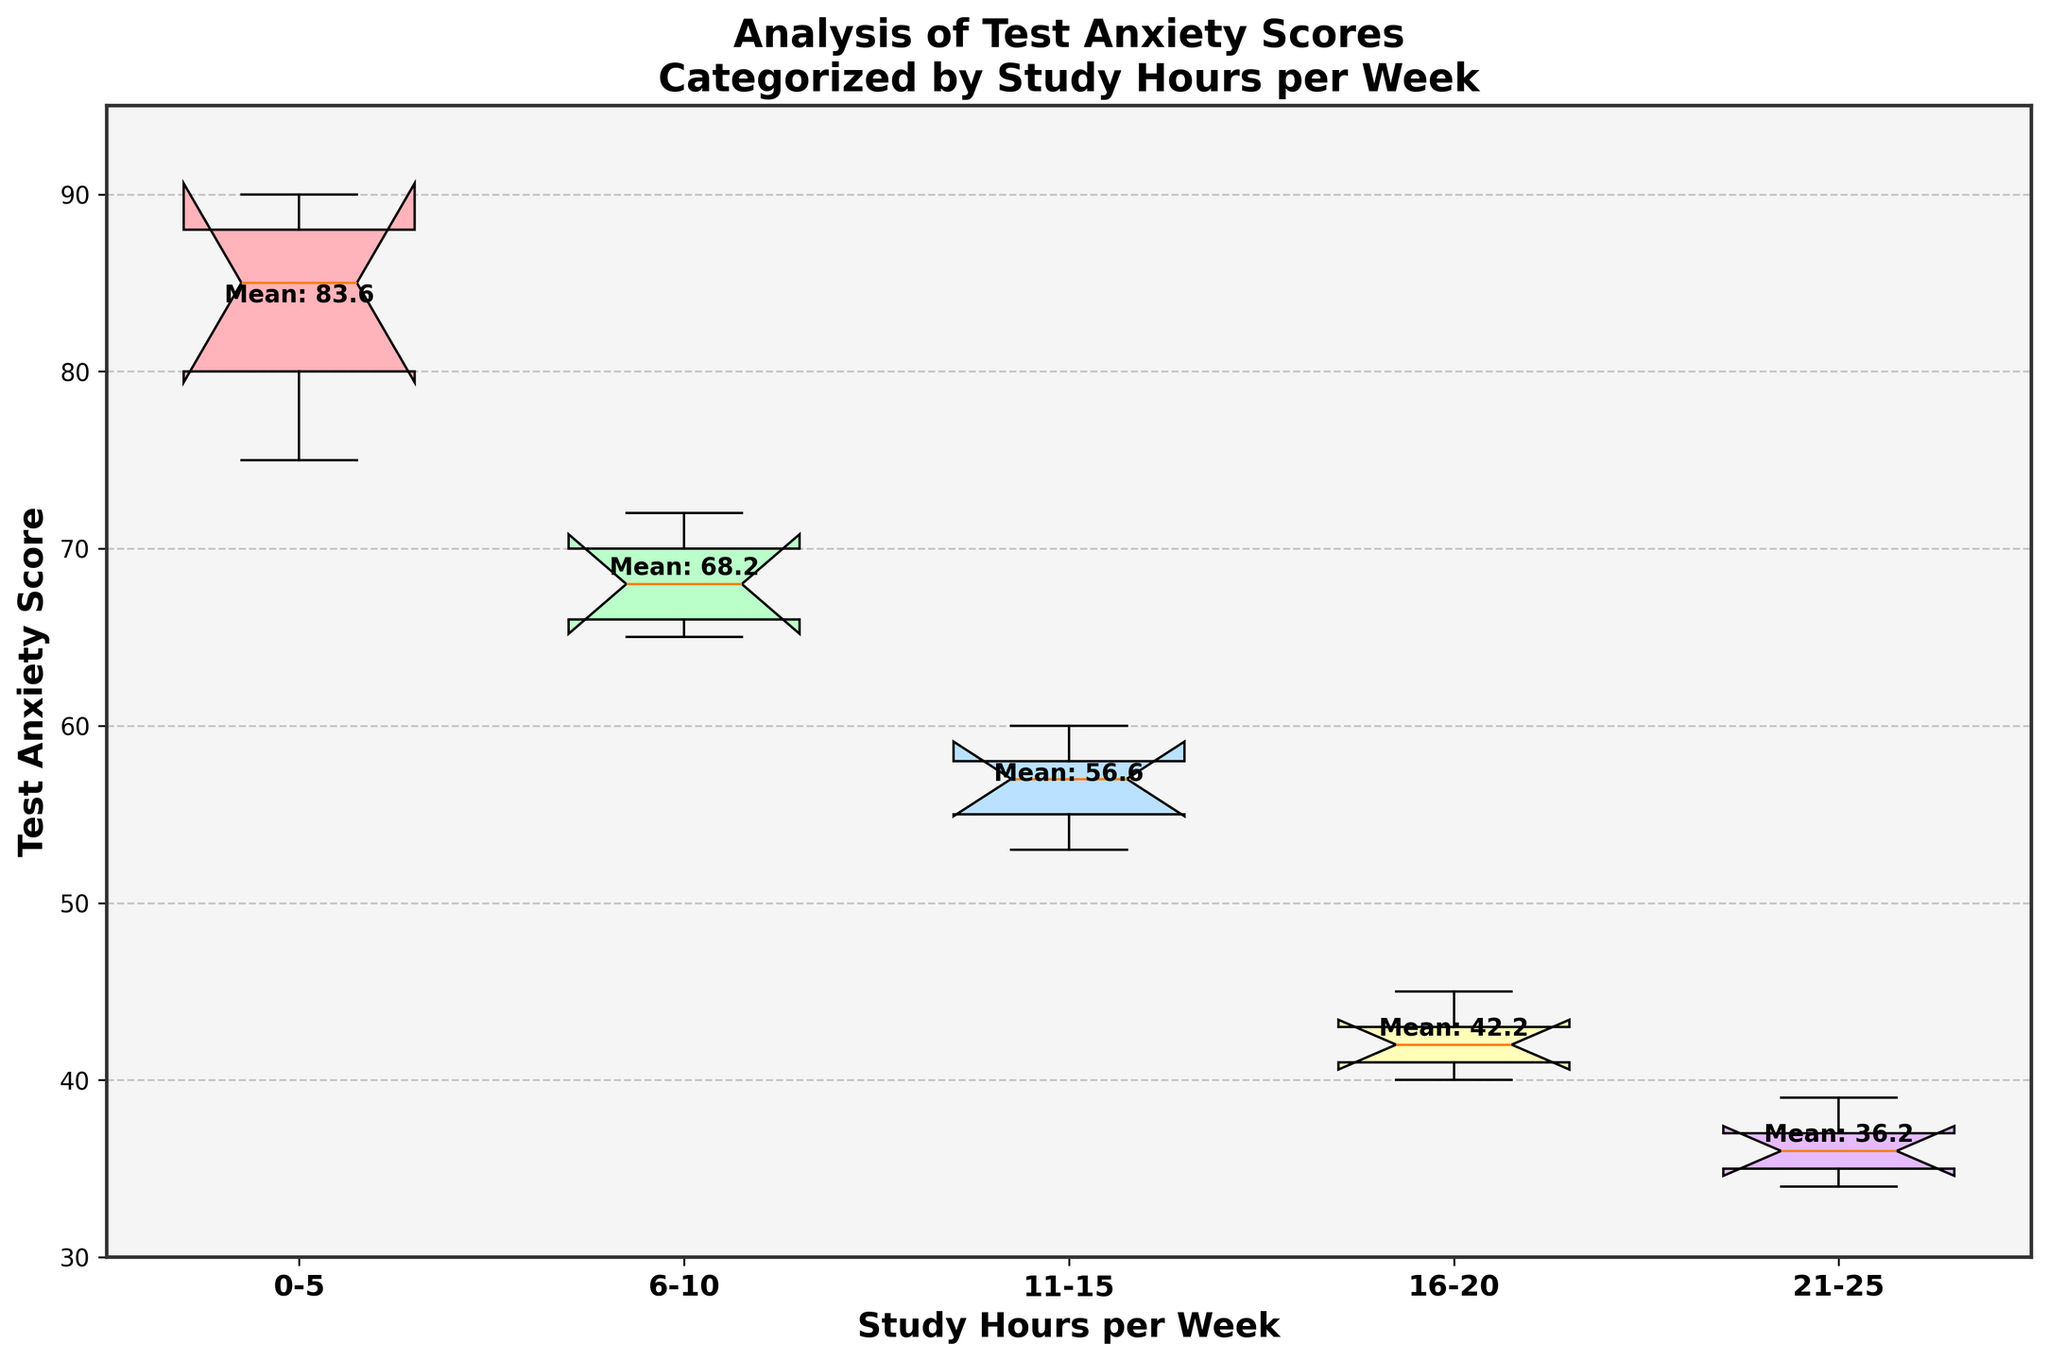What is the title of the plot? The title is displayed at the top of the figure and provides a summary of what the plot is about. It helps the viewer understand the context immediately.
Answer: Analysis of Test Anxiety Scores Categorized by Study Hours per Week What does the x-axis represent? The x-axis labels indicate the categories or groups, and in this plot, it represents the different ranges of study hours per week for students.
Answer: Study Hours per Week What does the y-axis represent? The y-axis labels indicate the numerical values being measured or compared across the x-axis categories. In this case, it represents the Test Anxiety Scores of students.
Answer: Test Anxiety Score Which group has the lowest median Test Anxiety Score? The median is represented by the horizontal line inside each box. By observing the positions of these lines, we see that the 21-25 study hours per week group has the lowest median.
Answer: 21-25 hours Which study hours group has the highest mean Test Anxiety Score? The mean values are annotated as text (e.g., "Mean: 40.2") near each group. By reviewing these text annotations, the group with the highest mean is 0-5 hours.
Answer: 0-5 hours Which study hours group shows the widest range of Test Anxiety Scores? The range can be determined by the distance between the lowest (bottom whisker) and highest (top whisker) data points. The 0-5 study hours per week group has the widest range, spanning from 75 to 90.
Answer: 0-5 hours In which group(s) are notches overlapping, and what does this signify? Overlapping notches indicate that there is no statistically significant difference between the medians of those groups. In the plot, it appears that the 6-10 and 11-15 study hours groups have overlapping notches.
Answer: 6-10 and 11-15 hours; no significant difference Compare the interquartile range (IQR) of students studying 16-20 hours per week to those studying 21-25 hours per week. The IQR is the length of the box in each plot, representing the middle 50% of the data. The IQR for 16-20 hours is larger than that for 21-25 hours, indicating more variability in the middle scores of the former group.
Answer: 16-20 hours > 21-25 hours 